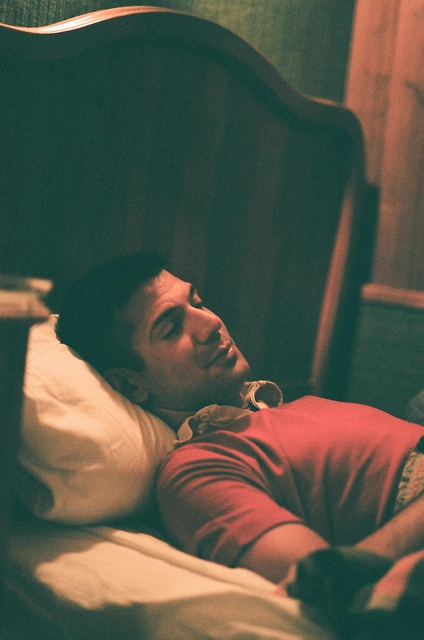Describe the objects in this image and their specific colors. I can see people in teal, black, gray, salmon, and brown tones and bed in teal, gray, and tan tones in this image. 